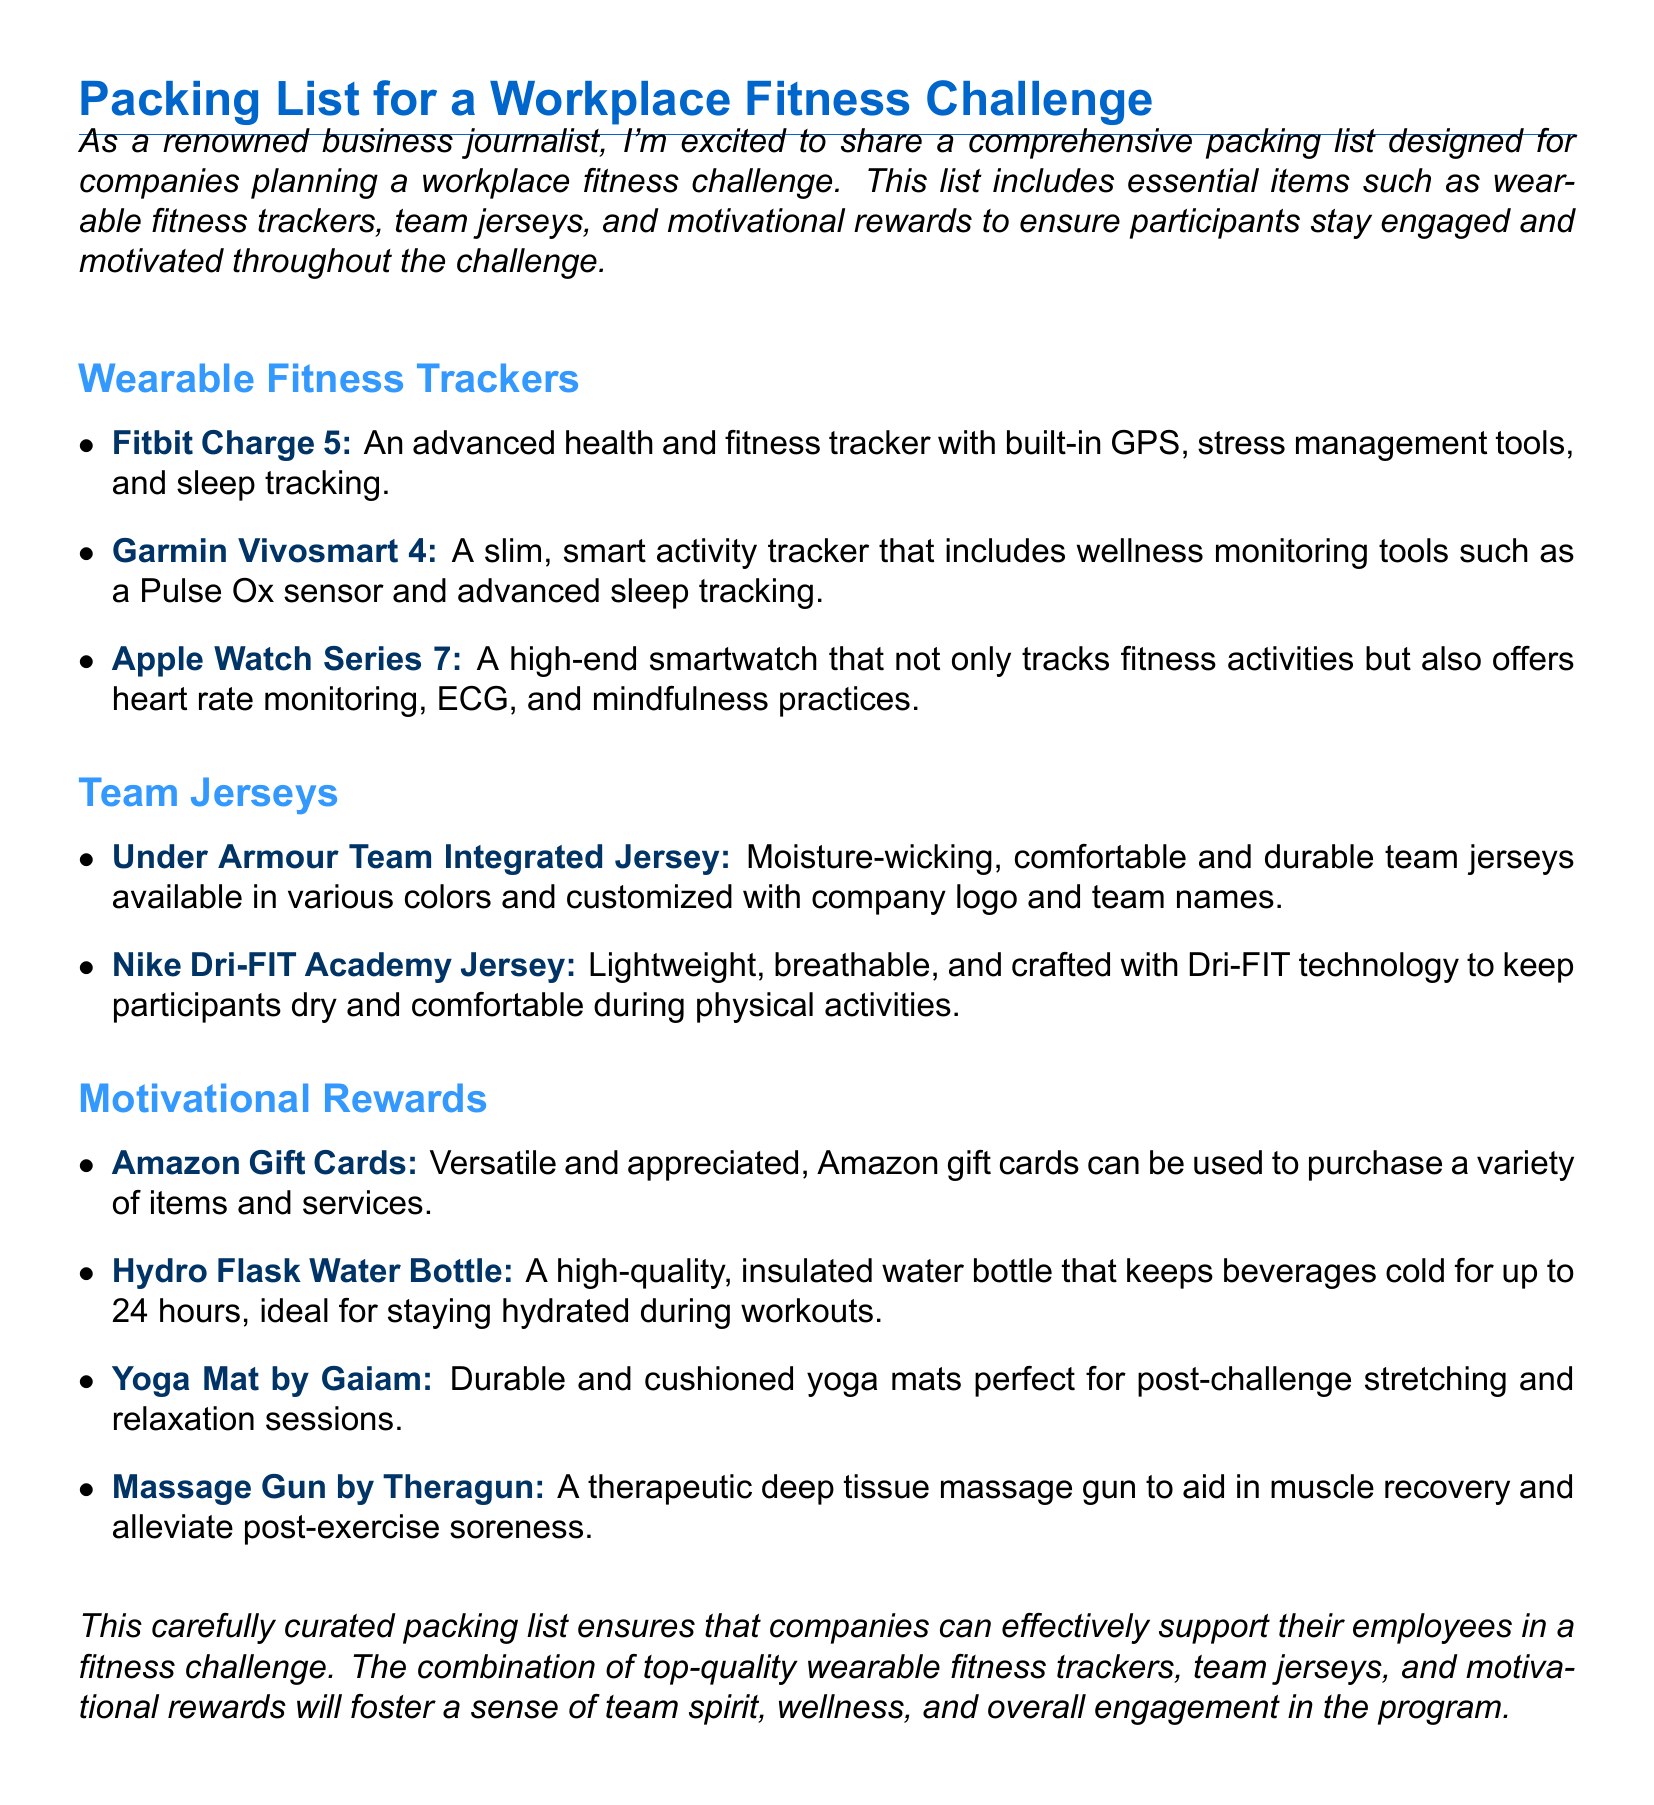What is the title of the document? The title of the document is presented prominently at the top and summarizes its main focus, which is a "Packing List for a Workplace Fitness Challenge."
Answer: Packing List for a Workplace Fitness Challenge How many wearable fitness trackers are listed? The document includes a specific count of items in the wearable fitness trackers section. There are three items listed.
Answer: 3 What brand is associated with the team jerseys mentioned? The document names specific brands associated with team jerseys, including Under Armour and Nike.
Answer: Under Armour, Nike What type of rewards are Amazon Gift Cards classified as? The rewards section specifies the type of motivational rewards, identifying Amazon Gift Cards as versatile and appreciated.
Answer: Motivational Rewards Which wearable fitness tracker offers stress management tools? The document specifies features of wearable fitness trackers, stating that the Fitbit Charge 5 includes stress management tools.
Answer: Fitbit Charge 5 What is the purpose of the Hydro Flask Water Bottle? The document explains that the Hydro Flask Water Bottle is intended to keep beverages cold for up to 24 hours, ideal for hydration during workouts.
Answer: Staying hydrated What technology is used in the Nike Dri-FIT Academy Jersey? The document references specific technology used in the Nike Dri-FIT Academy Jersey, which is crafted with Dri-FIT technology.
Answer: Dri-FIT technology What does the Yoga Mat by Gaiam help with? The document clarifies the purpose of the Yoga Mat by Gaiam, which is perfect for post-challenge stretching and relaxation sessions.
Answer: Stretching and relaxation 